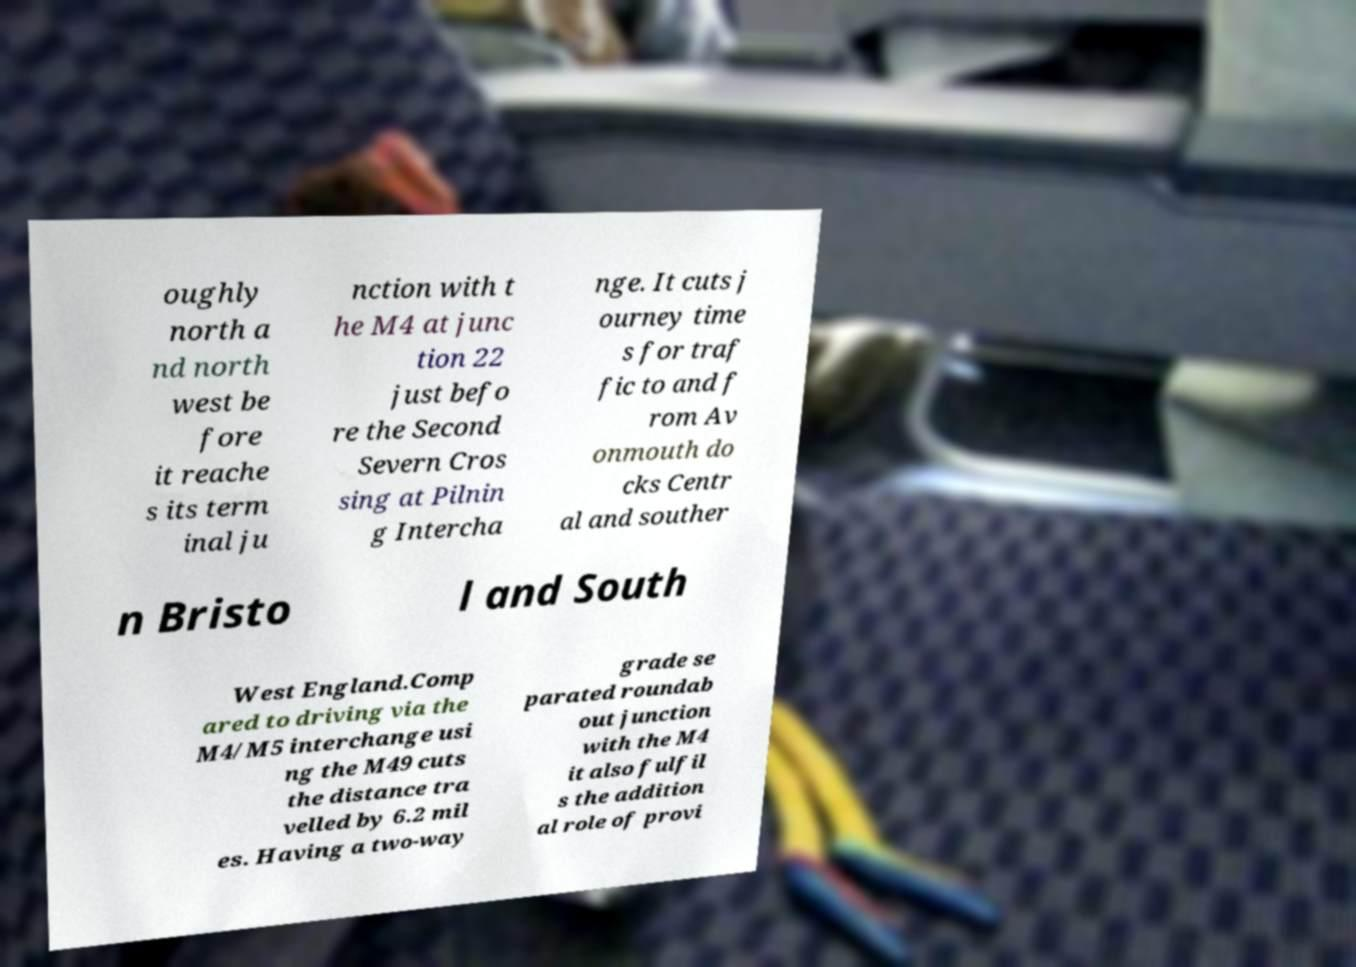Please identify and transcribe the text found in this image. oughly north a nd north west be fore it reache s its term inal ju nction with t he M4 at junc tion 22 just befo re the Second Severn Cros sing at Pilnin g Intercha nge. It cuts j ourney time s for traf fic to and f rom Av onmouth do cks Centr al and souther n Bristo l and South West England.Comp ared to driving via the M4/M5 interchange usi ng the M49 cuts the distance tra velled by 6.2 mil es. Having a two-way grade se parated roundab out junction with the M4 it also fulfil s the addition al role of provi 